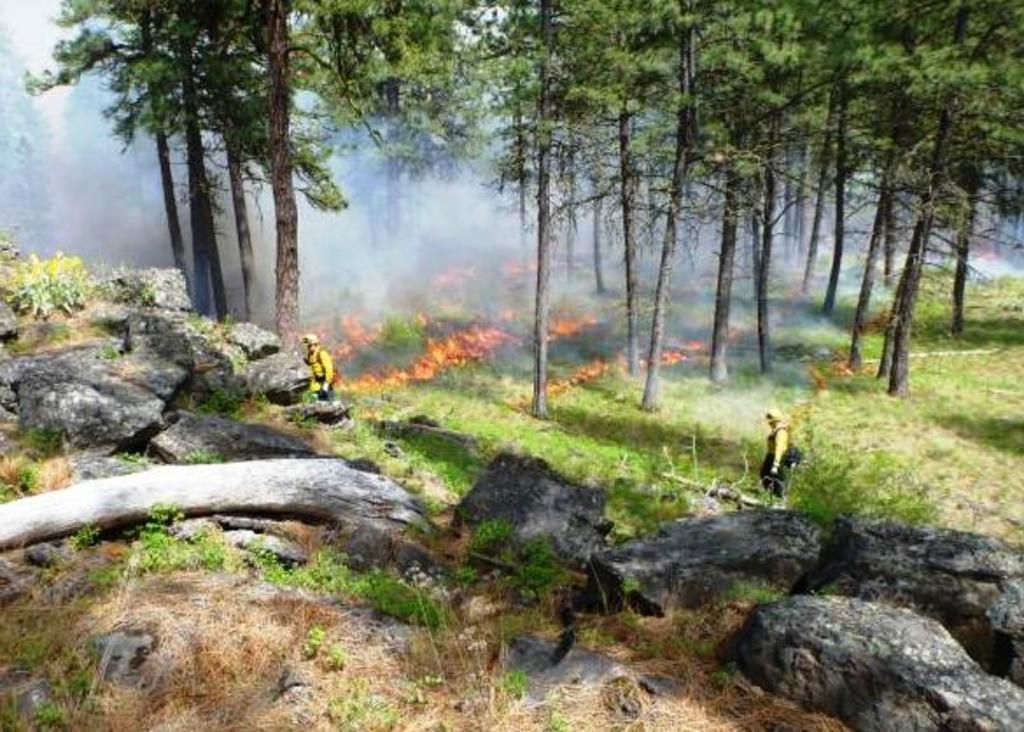What is happening in the forest in the image? The forest is on fire in the image. Who is present in the image trying to address the fire? There are two firefighters in the image. What are the firefighters doing in the image? The firefighters are trying to put off the fire. What type of natural environment is depicted in the image? There are trees and rocks in the image. Can you see the friend of the firefighter in the image? There is no friend of the firefighter present in the image. What type of curtain can be seen in the image? There is no curtain present in the image. 